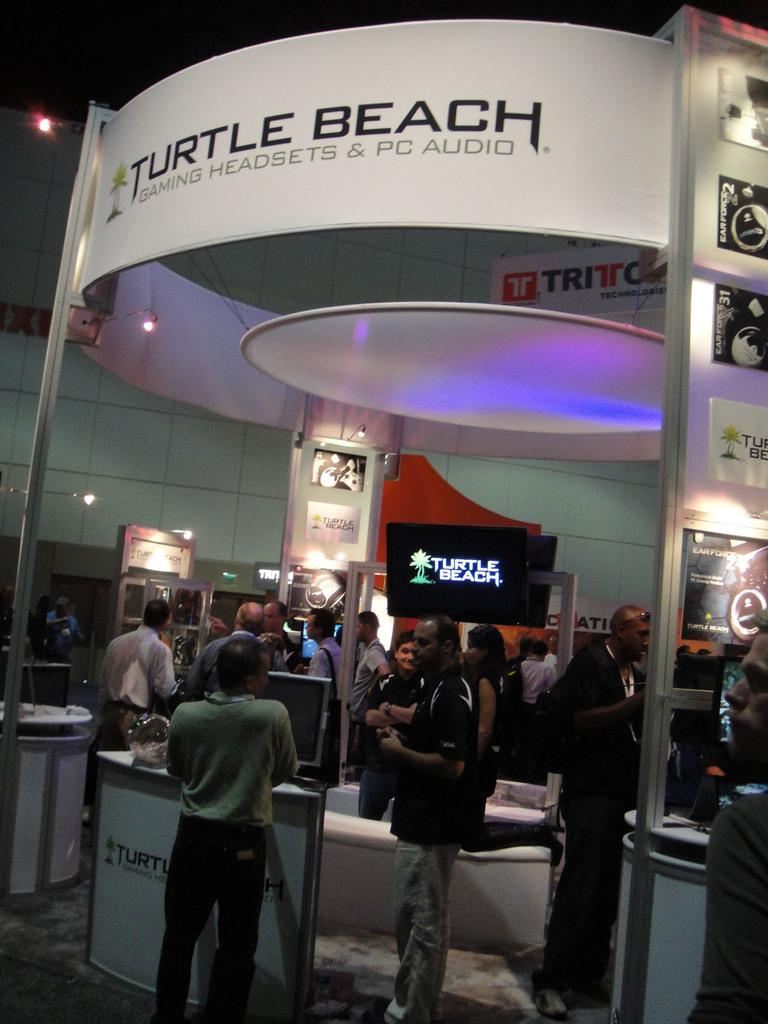What can be seen in the image involving groups of people? There are groups of people standing in the image. What are the people facing or interacting with in the image? The people are facing televisions, boards, and lights in front of them. Can you describe the objects in front of the people? There are some objects in front of the people, but their specific nature is not mentioned in the facts. What type of vein is visible in the image? There is no mention of a vein in the image, so it cannot be seen or described. 